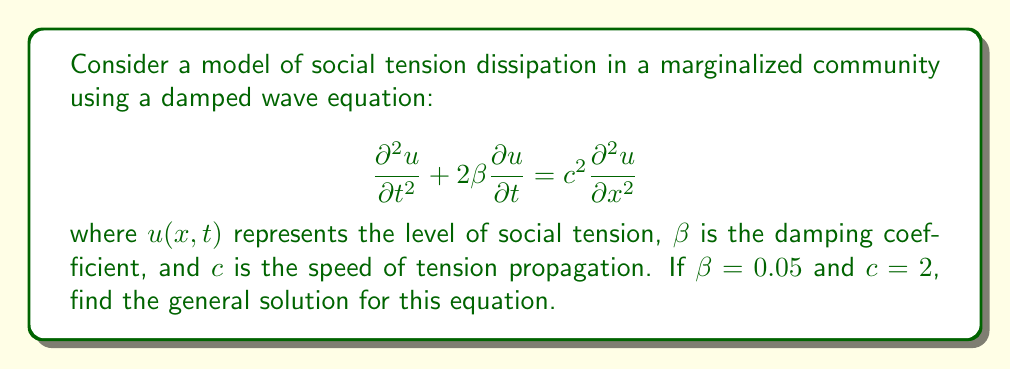Can you solve this math problem? To solve this damped wave equation, we'll follow these steps:

1) First, assume a solution of the form $u(x,t) = X(x)T(t)$.

2) Substituting this into the original equation:

   $$X(x)T''(t) + 2\beta X(x)T'(t) = c^2 X''(x)T(t)$$

3) Divide both sides by $X(x)T(t)$:

   $$\frac{T''(t)}{T(t)} + 2\beta \frac{T'(t)}{T(t)} = c^2 \frac{X''(x)}{X(x)}$$

4) Since the left side depends only on $t$ and the right side only on $x$, both must equal a constant. Let's call this constant $-k^2$:

   $$\frac{T''(t)}{T(t)} + 2\beta \frac{T'(t)}{T(t)} = -k^2 = c^2 \frac{X''(x)}{X(x)}$$

5) For the spatial part, we get:

   $$X''(x) + \frac{k^2}{c^2}X(x) = 0$$

   This has the general solution: $X(x) = A \cos(\frac{kx}{c}) + B \sin(\frac{kx}{c})$

6) For the temporal part, we have:

   $$T''(t) + 2\beta T'(t) + k^2T(t) = 0$$

   This is a second-order ODE with characteristic equation:

   $$r^2 + 2\beta r + k^2 = 0$$

7) Solving this characteristic equation:

   $$r = -\beta \pm \sqrt{\beta^2 - k^2}$$

8) The nature of the solution depends on whether $\beta^2 - k^2$ is positive, negative, or zero. Given $\beta = 0.05$, it's likely that $\beta^2 < k^2$ for most meaningful $k$ values. In this case:

   $$T(t) = e^{-\beta t}(C \cos(\omega t) + D \sin(\omega t))$$

   where $\omega = \sqrt{k^2 - \beta^2}$

9) Combining the spatial and temporal solutions:

   $$u(x,t) = e^{-\beta t}(C \cos(\omega t) + D \sin(\omega t))(A \cos(\frac{kx}{c}) + B \sin(\frac{kx}{c}))$$

10) Expanding this:

    $$u(x,t) = e^{-0.05t}(E \cos(\omega t) \cos(\frac{kx}{2}) + F \cos(\omega t) \sin(\frac{kx}{2}) + G \sin(\omega t) \cos(\frac{kx}{2}) + H \sin(\omega t) \sin(\frac{kx}{2}))$$

    where $E, F, G, H$ are arbitrary constants.
Answer: $u(x,t) = e^{-0.05t}(E \cos(\omega t) \cos(\frac{kx}{2}) + F \cos(\omega t) \sin(\frac{kx}{2}) + G \sin(\omega t) \cos(\frac{kx}{2}) + H \sin(\omega t) \sin(\frac{kx}{2}))$ 